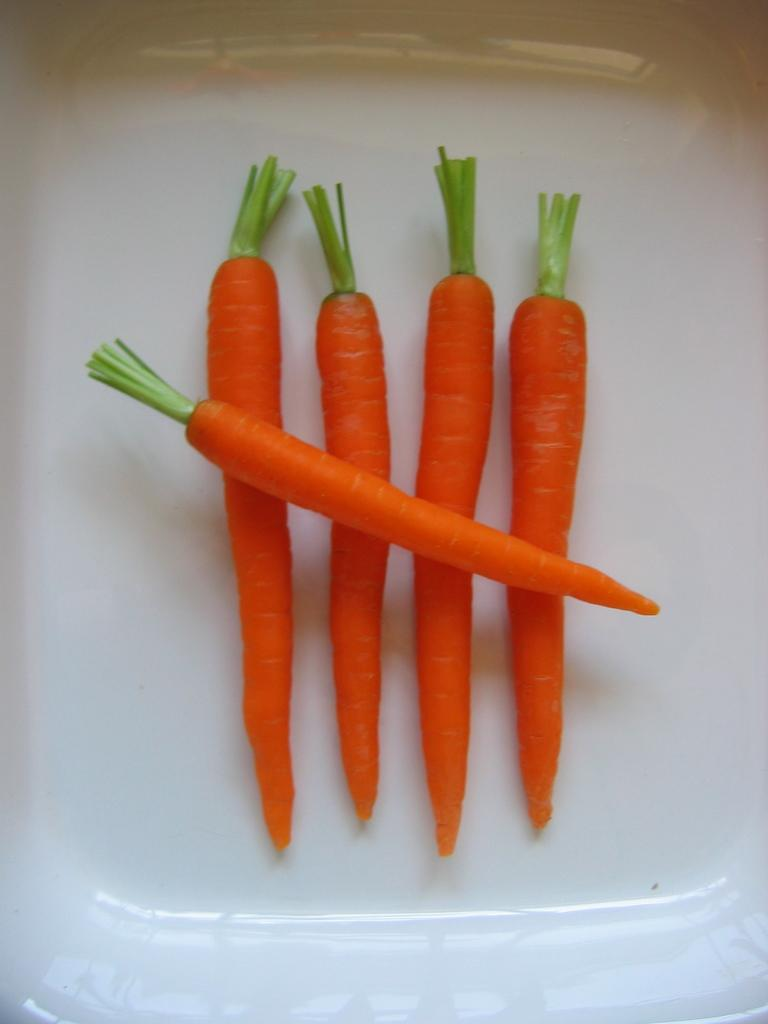What object can be seen in the image that is typically used for serving food? There is a plate in the image. How many carrots are on the plate? There are five carrots on the plate. What type of juice is being served in the club in the image? There is no juice or club present in the image; it only features a plate with five carrots on it. 